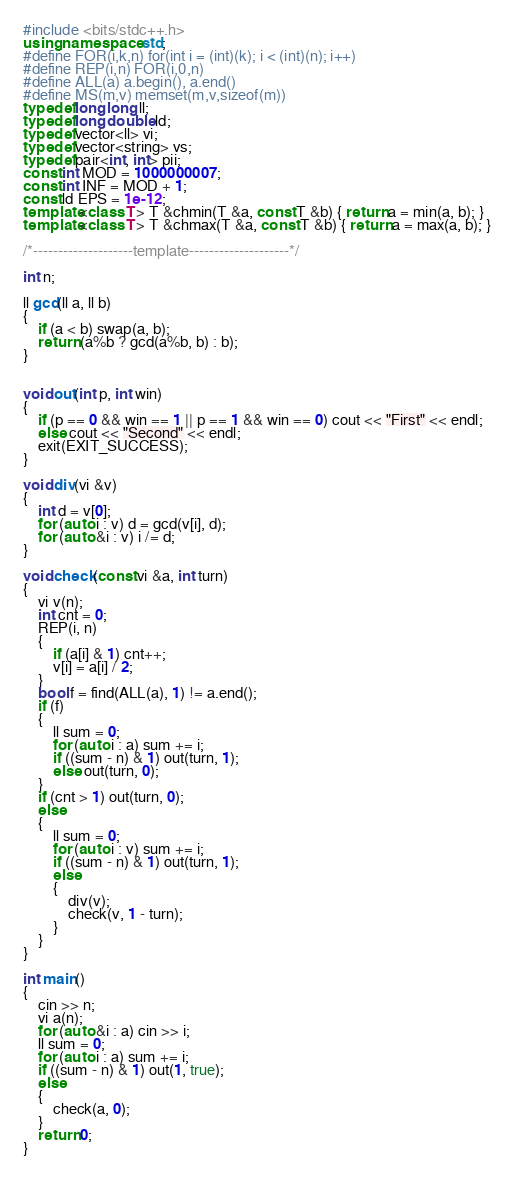<code> <loc_0><loc_0><loc_500><loc_500><_C++_>#include <bits/stdc++.h>
using namespace std;
#define FOR(i,k,n) for(int i = (int)(k); i < (int)(n); i++)
#define REP(i,n) FOR(i,0,n)
#define ALL(a) a.begin(), a.end()
#define MS(m,v) memset(m,v,sizeof(m))
typedef long long ll;
typedef long double ld;
typedef vector<ll> vi;
typedef vector<string> vs;
typedef pair<int, int> pii;
const int MOD = 1000000007;
const int INF = MOD + 1;
const ld EPS = 1e-12;
template<class T> T &chmin(T &a, const T &b) { return a = min(a, b); }
template<class T> T &chmax(T &a, const T &b) { return a = max(a, b); }

/*--------------------template--------------------*/

int n;

ll gcd(ll a, ll b)
{
	if (a < b) swap(a, b);
	return (a%b ? gcd(a%b, b) : b);
}


void out(int p, int win)
{
	if (p == 0 && win == 1 || p == 1 && win == 0) cout << "First" << endl;
	else cout << "Second" << endl;
	exit(EXIT_SUCCESS);
}

void div(vi &v)
{
	int d = v[0];
	for (auto i : v) d = gcd(v[i], d);
	for (auto &i : v) i /= d;
}

void check(const vi &a, int turn)
{
	vi v(n);
	int cnt = 0;
	REP(i, n)
	{
		if (a[i] & 1) cnt++;
		v[i] = a[i] / 2;
	}
	bool f = find(ALL(a), 1) != a.end();
	if (f)
	{
		ll sum = 0;
		for (auto i : a) sum += i;
		if ((sum - n) & 1) out(turn, 1);
		else out(turn, 0);
	}
	if (cnt > 1) out(turn, 0);
	else
	{
		ll sum = 0;
		for (auto i : v) sum += i;
		if ((sum - n) & 1) out(turn, 1);
		else
		{
			div(v);
			check(v, 1 - turn);
		}
	}
}

int main()
{
	cin >> n;
	vi a(n);
	for (auto &i : a) cin >> i;
	ll sum = 0;
	for (auto i : a) sum += i;
	if ((sum - n) & 1) out(1, true);
	else
	{
		check(a, 0);
	}
	return 0;
}</code> 